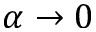Convert formula to latex. <formula><loc_0><loc_0><loc_500><loc_500>\alpha \to 0</formula> 